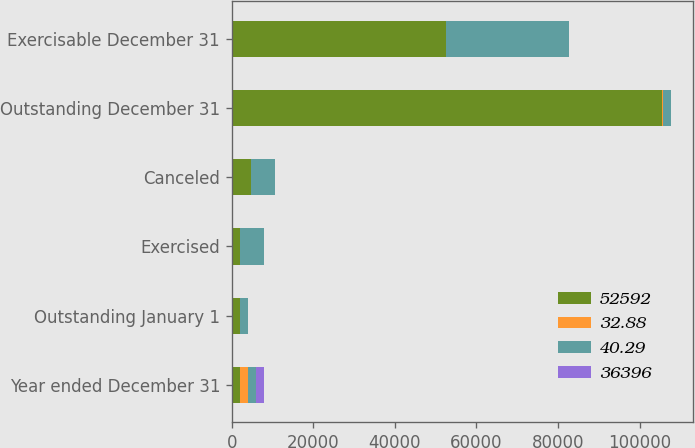Convert chart. <chart><loc_0><loc_0><loc_500><loc_500><stacked_bar_chart><ecel><fcel>Year ended December 31<fcel>Outstanding January 1<fcel>Exercised<fcel>Canceled<fcel>Outstanding December 31<fcel>Exercisable December 31<nl><fcel>52592<fcel>2005<fcel>2000<fcel>2000<fcel>4602<fcel>105582<fcel>52592<nl><fcel>32.88<fcel>2005<fcel>40.42<fcel>24.1<fcel>39.27<fcel>40.78<fcel>40.29<nl><fcel>40.29<fcel>2004<fcel>2000<fcel>5960<fcel>5999<fcel>2000<fcel>30082<nl><fcel>36396<fcel>2004<fcel>39.11<fcel>15.26<fcel>39.18<fcel>40.42<fcel>36.33<nl></chart> 